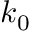Convert formula to latex. <formula><loc_0><loc_0><loc_500><loc_500>k _ { 0 }</formula> 